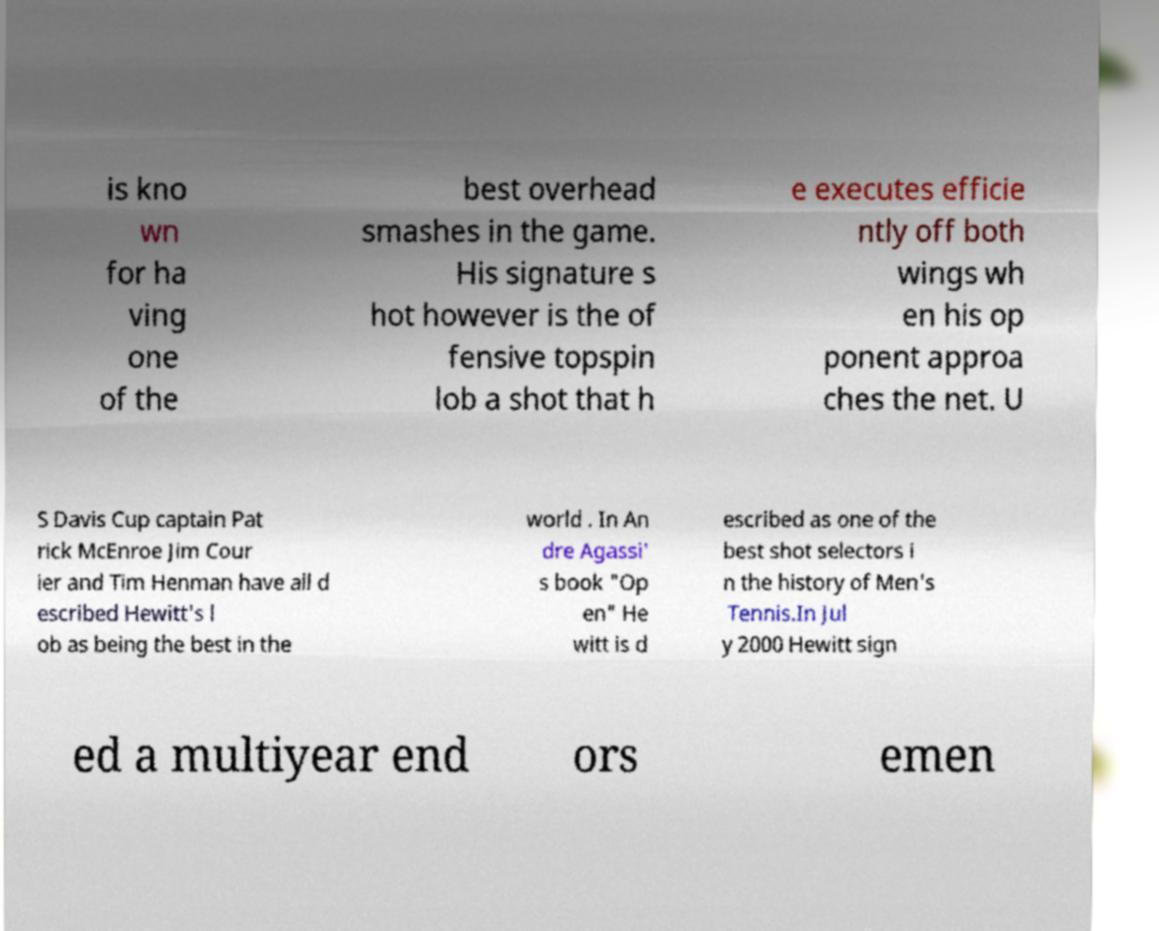Can you read and provide the text displayed in the image?This photo seems to have some interesting text. Can you extract and type it out for me? is kno wn for ha ving one of the best overhead smashes in the game. His signature s hot however is the of fensive topspin lob a shot that h e executes efficie ntly off both wings wh en his op ponent approa ches the net. U S Davis Cup captain Pat rick McEnroe Jim Cour ier and Tim Henman have all d escribed Hewitt's l ob as being the best in the world . In An dre Agassi' s book "Op en" He witt is d escribed as one of the best shot selectors i n the history of Men's Tennis.In Jul y 2000 Hewitt sign ed a multiyear end ors emen 